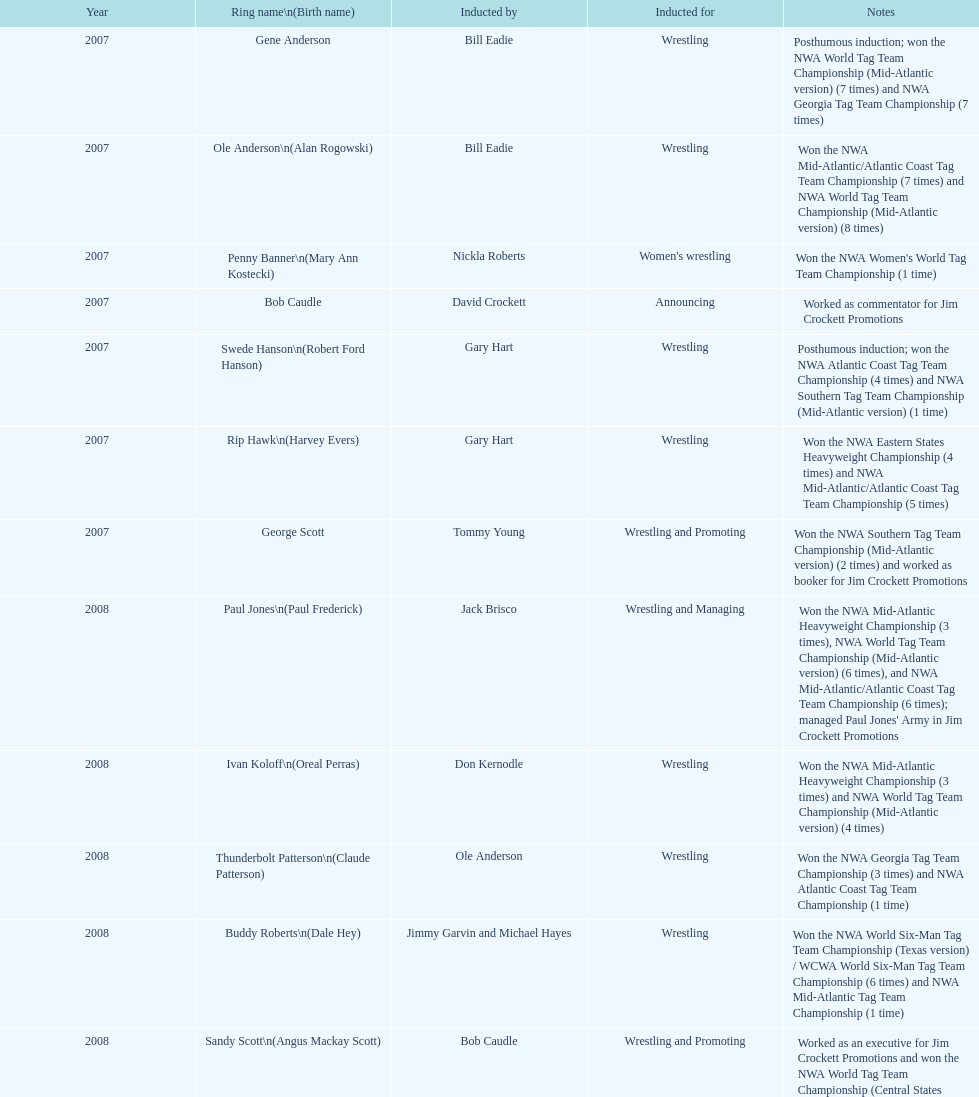Inform me about an inductee who was deceased at the moment. Gene Anderson. 